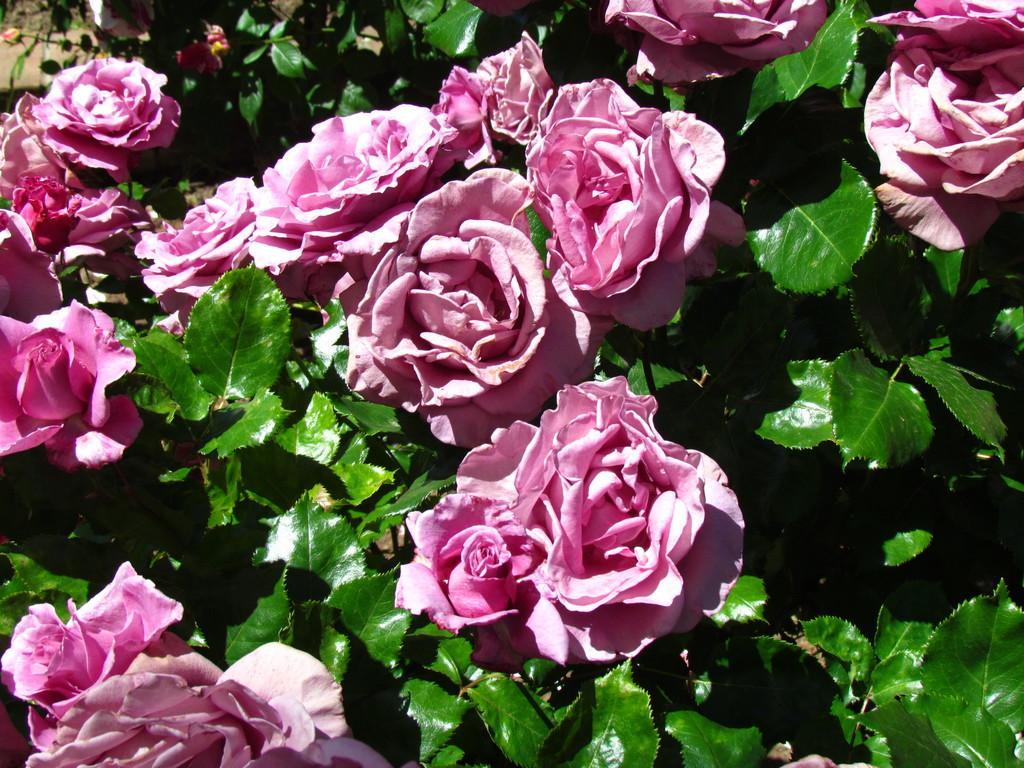Please provide a concise description of this image. Here we can see flowers and plants. 